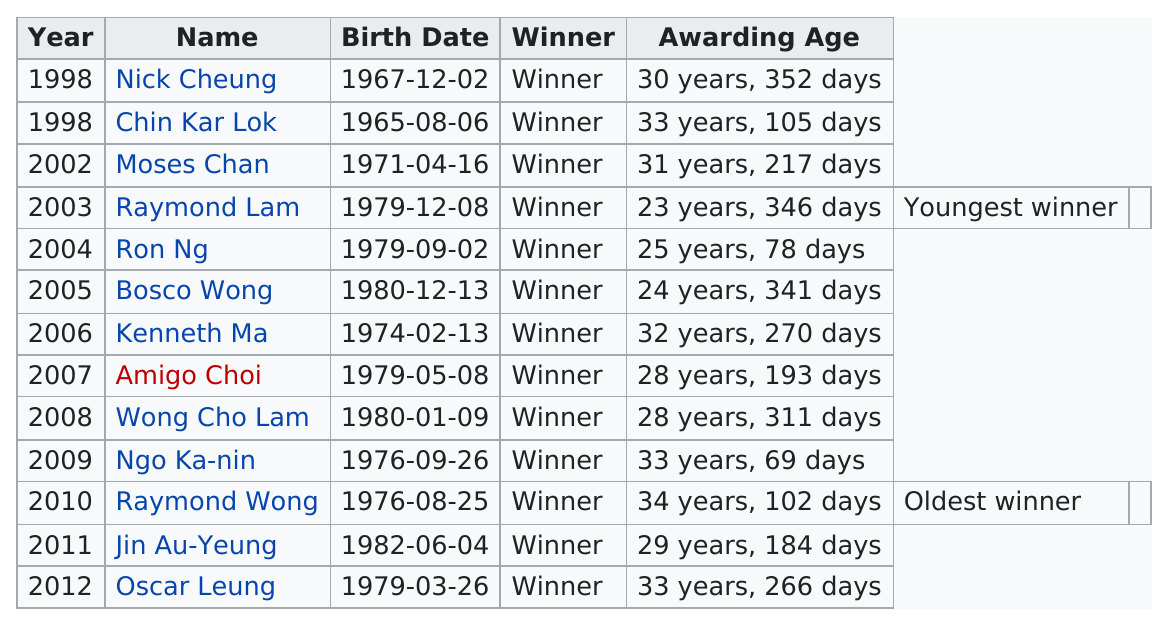Outline some significant characteristics in this image. Nick Cheung won this award in the same year as Chin Kar Lok, who also won this award. There were four winners who were born in 1979. There were 13 winners from 1998 to 2012. Jin Au-Yeung was the winner in 2011, and the next winner after him was Oscar Leung. Choi is the same number of years old as Wong Cho Lam. 